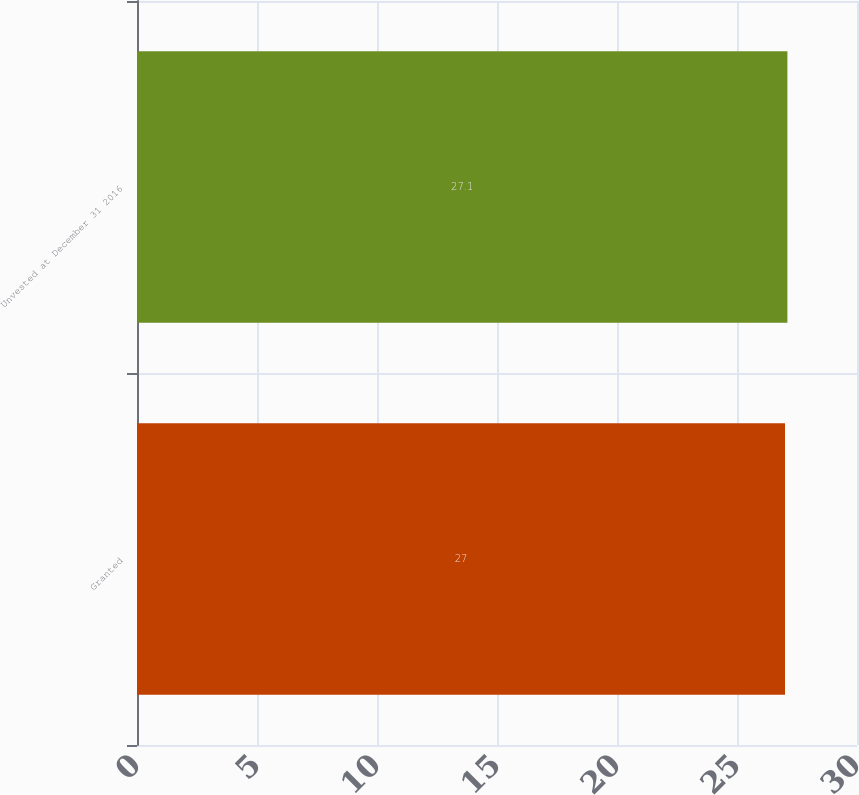Convert chart. <chart><loc_0><loc_0><loc_500><loc_500><bar_chart><fcel>Granted<fcel>Unvested at December 31 2016<nl><fcel>27<fcel>27.1<nl></chart> 